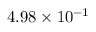Convert formula to latex. <formula><loc_0><loc_0><loc_500><loc_500>4 . 9 8 \times 1 0 ^ { - 1 }</formula> 